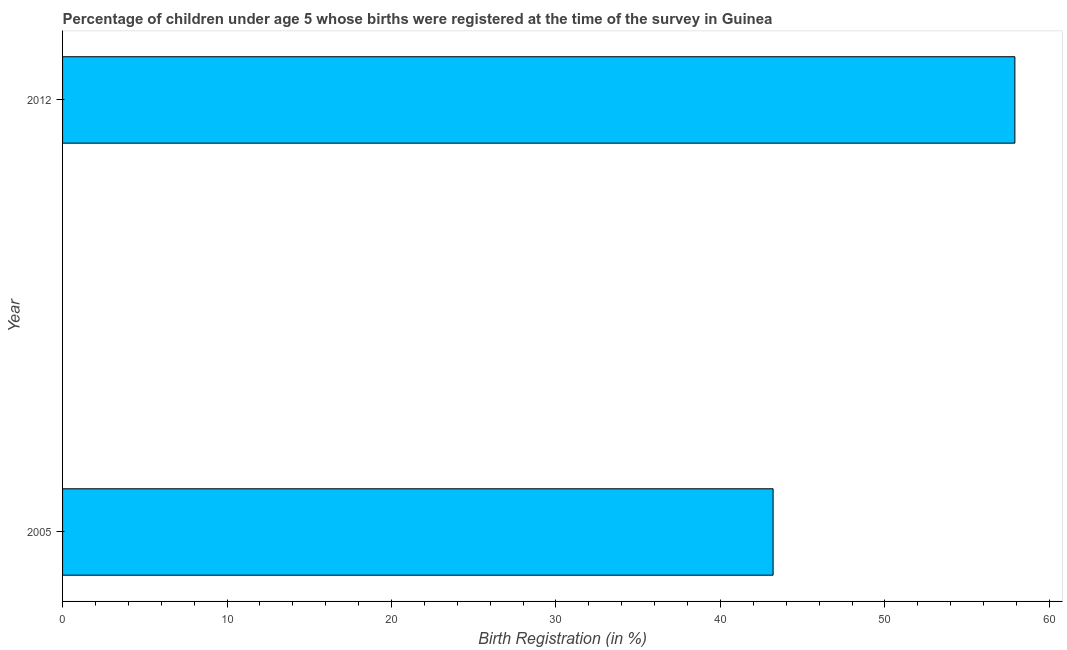Does the graph contain grids?
Give a very brief answer. No. What is the title of the graph?
Offer a very short reply. Percentage of children under age 5 whose births were registered at the time of the survey in Guinea. What is the label or title of the X-axis?
Provide a succinct answer. Birth Registration (in %). What is the label or title of the Y-axis?
Your response must be concise. Year. What is the birth registration in 2005?
Your answer should be very brief. 43.2. Across all years, what is the maximum birth registration?
Your answer should be very brief. 57.9. Across all years, what is the minimum birth registration?
Give a very brief answer. 43.2. In which year was the birth registration minimum?
Keep it short and to the point. 2005. What is the sum of the birth registration?
Ensure brevity in your answer.  101.1. What is the difference between the birth registration in 2005 and 2012?
Ensure brevity in your answer.  -14.7. What is the average birth registration per year?
Offer a terse response. 50.55. What is the median birth registration?
Offer a very short reply. 50.55. Do a majority of the years between 2012 and 2005 (inclusive) have birth registration greater than 58 %?
Offer a very short reply. No. What is the ratio of the birth registration in 2005 to that in 2012?
Your answer should be very brief. 0.75. Is the birth registration in 2005 less than that in 2012?
Give a very brief answer. Yes. How many bars are there?
Offer a very short reply. 2. Are all the bars in the graph horizontal?
Provide a short and direct response. Yes. How many years are there in the graph?
Your response must be concise. 2. What is the difference between two consecutive major ticks on the X-axis?
Give a very brief answer. 10. What is the Birth Registration (in %) of 2005?
Ensure brevity in your answer.  43.2. What is the Birth Registration (in %) of 2012?
Your response must be concise. 57.9. What is the difference between the Birth Registration (in %) in 2005 and 2012?
Provide a short and direct response. -14.7. What is the ratio of the Birth Registration (in %) in 2005 to that in 2012?
Your response must be concise. 0.75. 